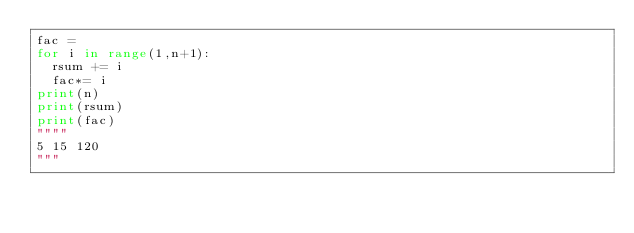<code> <loc_0><loc_0><loc_500><loc_500><_Python_>fac =
for i in range(1,n+1):
	rsum += i
	fac*= i
print(n)
print(rsum)
print(fac)
""""
5 15 120
"""
</code> 